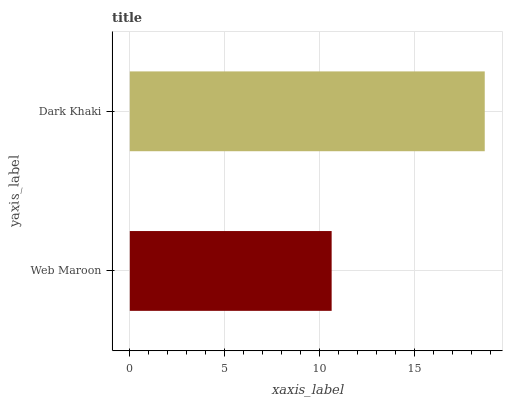Is Web Maroon the minimum?
Answer yes or no. Yes. Is Dark Khaki the maximum?
Answer yes or no. Yes. Is Dark Khaki the minimum?
Answer yes or no. No. Is Dark Khaki greater than Web Maroon?
Answer yes or no. Yes. Is Web Maroon less than Dark Khaki?
Answer yes or no. Yes. Is Web Maroon greater than Dark Khaki?
Answer yes or no. No. Is Dark Khaki less than Web Maroon?
Answer yes or no. No. Is Dark Khaki the high median?
Answer yes or no. Yes. Is Web Maroon the low median?
Answer yes or no. Yes. Is Web Maroon the high median?
Answer yes or no. No. Is Dark Khaki the low median?
Answer yes or no. No. 